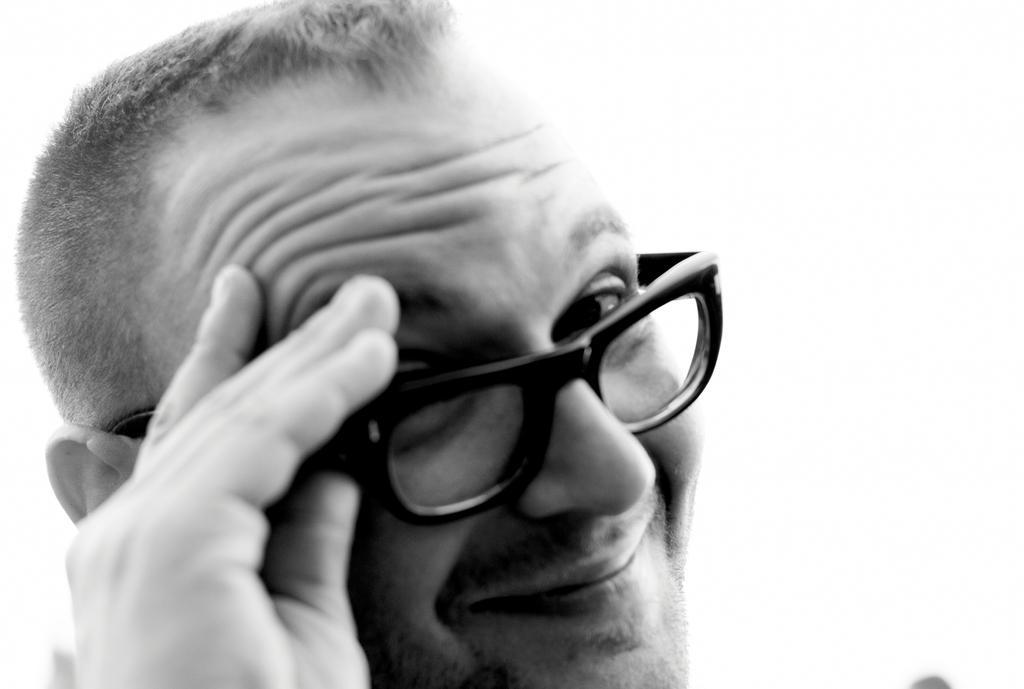Describe this image in one or two sentences. This is a black and white image in this image there is a man wearing glasses. 